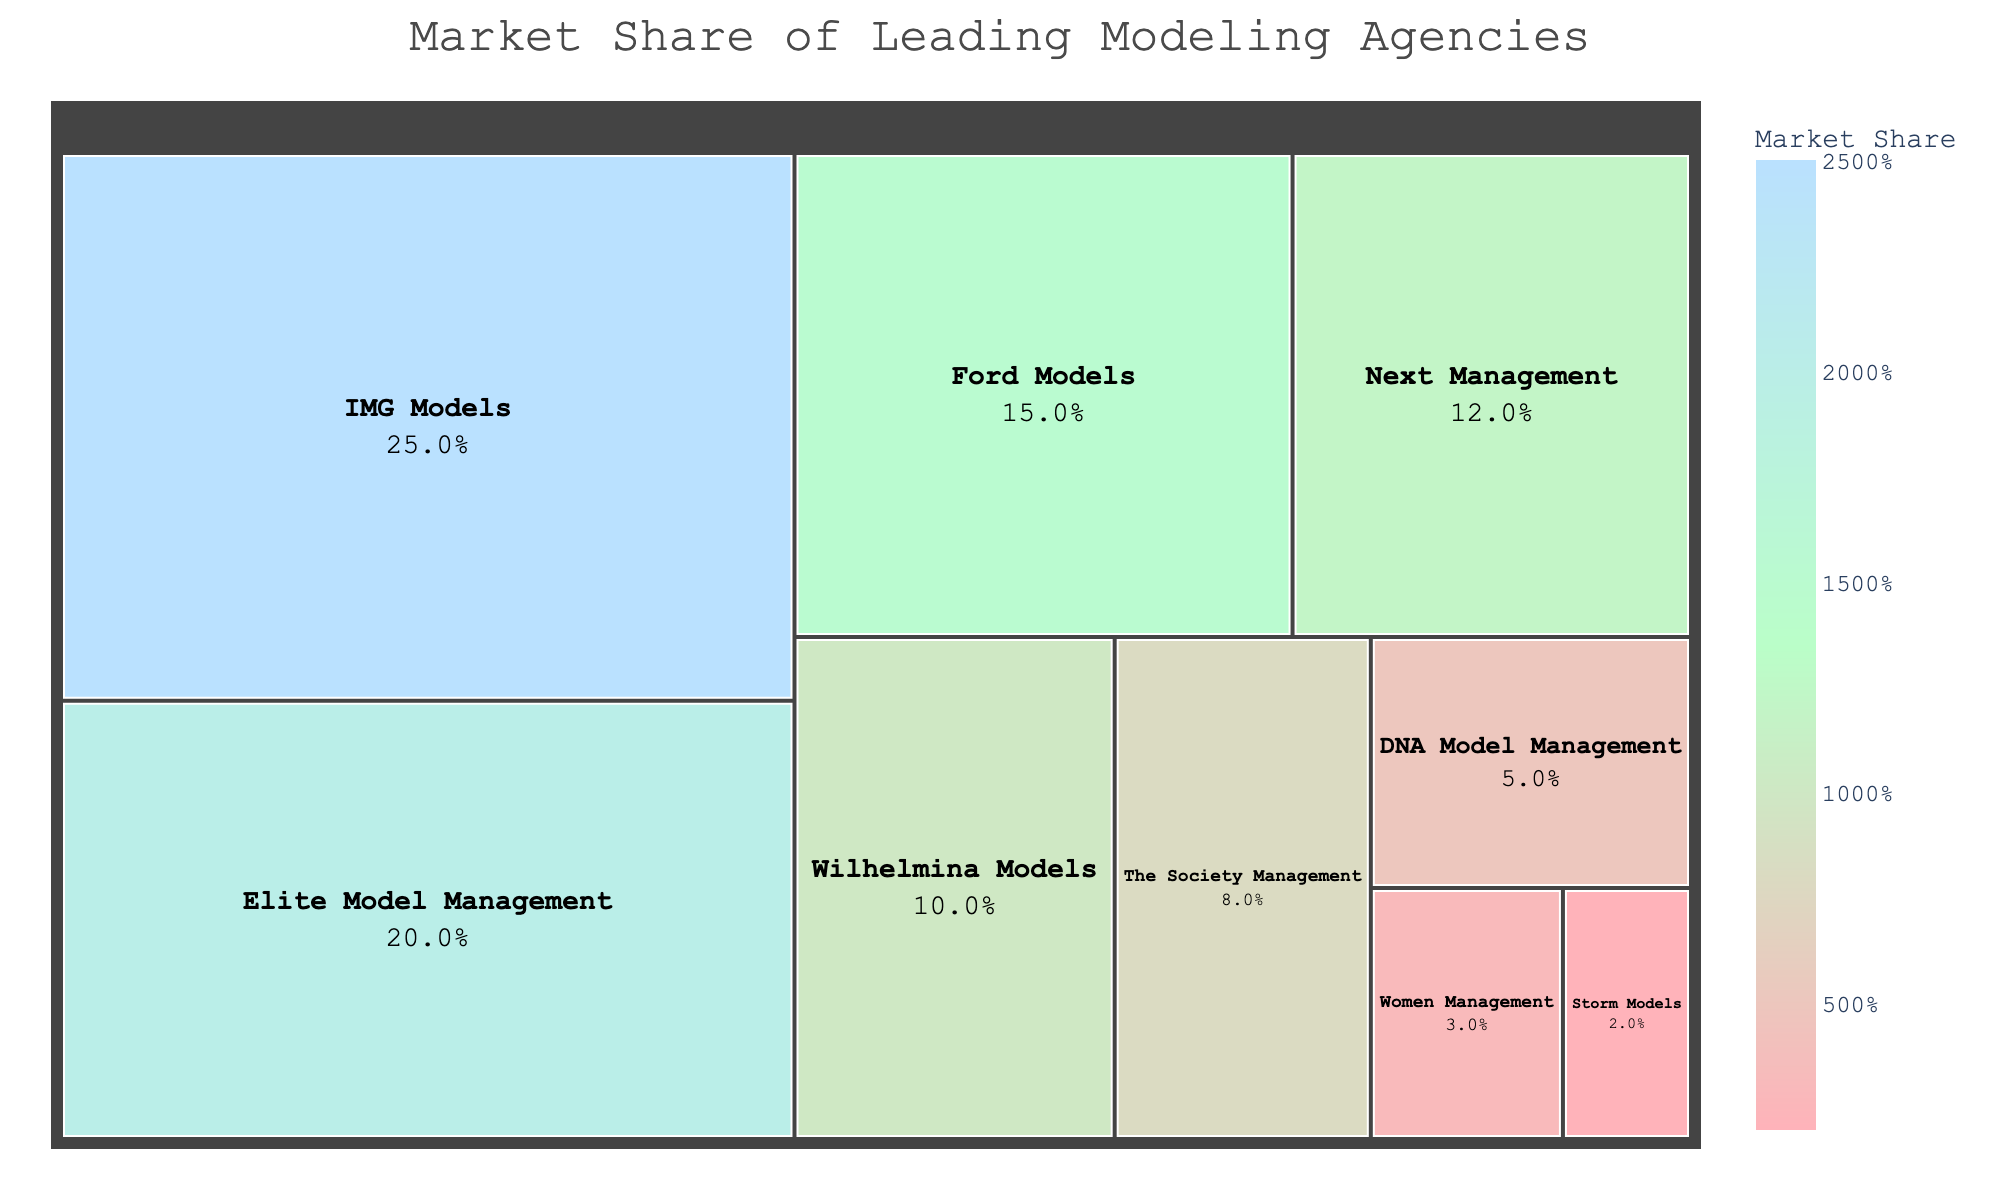How much market share does IMG Models have? The treemap shows each agency with its market share. By looking at the rectangle for IMG Models, we can see its market share percentage.
Answer: 25% What is the smallest market share represented in the treemap? By observing the smallest rectangle on the treemap, you can identify that Storm Models has the smallest market share.
Answer: 2% Which agency has a higher market share, Ford Models or Next Management? By comparing the relative sizes of the rectangles for Ford Models and Next Management on the treemap, you can see that Ford Models has a higher market share.
Answer: Ford Models What is the combined market share of Elite Model Management and Wilhelmina Models? Adding the market shares of Elite Model Management (20%) and Wilhelmina Models (10%) gives the combined market share.
Answer: 30% Among the listed agencies, which one has a market share closest to the average market share of all agencies? The total market share is 100%, and there are 9 agencies. The average market share is 100% / 9 ≈ 11.11%. Looking at the treemap, Next Management with 12% is closest to this average.
Answer: Next Management How many agencies have a market share of 10% or higher? Observing the treemap, the agencies with a market share of 10% or higher are IMG Models, Elite Model Management, Ford Models, Next Management, and Wilhelmina Models. Count these agencies.
Answer: 5 What is the difference in market share between the agency with the highest and the agency with the second highest market share? The highest market share is IMG Models with 25% and the second highest is Elite Model Management with 20%. The difference is 25% - 20%.
Answer: 5% How does the market share of The Society Management compare to Women Management? By comparing the size of the rectangles for The Society Management and Women Management, The Society Management has a market share of 8%, and Women Management has 3%.
Answer: Greater What percentage of the market is held by the top three agencies? Adding the market shares of the top three agencies: IMG Models (25%), Elite Model Management (20%), and Ford Models (15%) gives the percentage.
Answer: 60% Which color range is used to represent the market share, and what does it signify about the values? The treemap uses a color scale ranging from light pink to light blue. Generally, lighter colors represent lower market shares, and darker colors represent higher market shares.
Answer: Lighter colors: lower values; Darker colors: higher values 